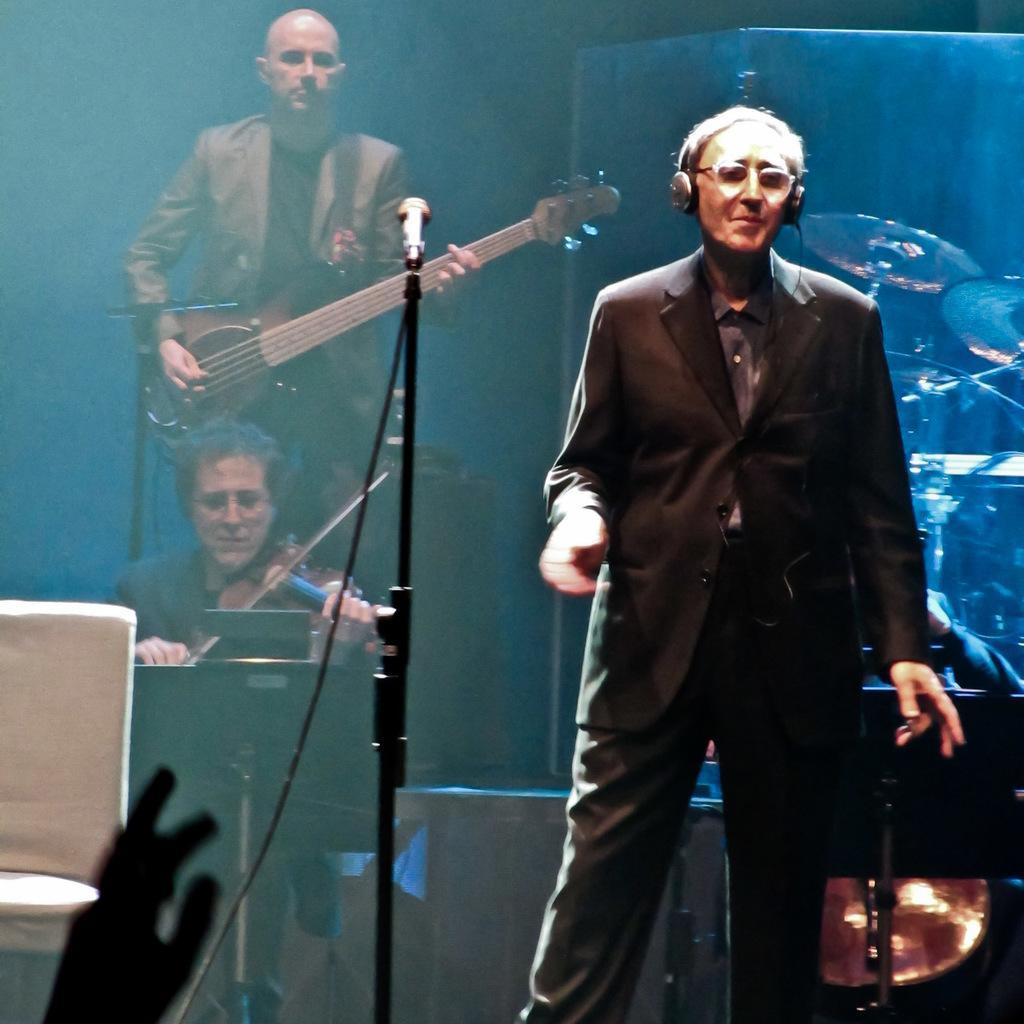Can you describe this image briefly? Here is the man standing,wearing headset. Here is the another person sitting and playing violin. This is the mike with the mike stand. At background I can see drums. Here is the another person standing and playing guitar. This looks like stage show. 